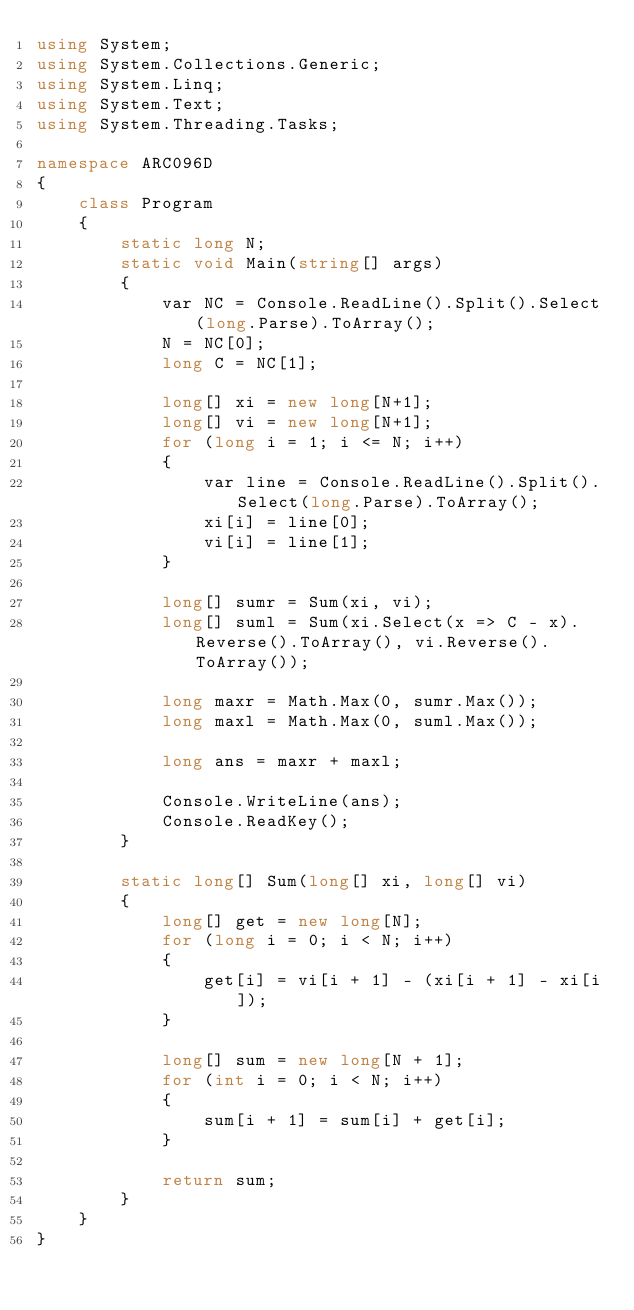Convert code to text. <code><loc_0><loc_0><loc_500><loc_500><_C#_>using System;
using System.Collections.Generic;
using System.Linq;
using System.Text;
using System.Threading.Tasks;

namespace ARC096D
{
    class Program
    {
        static long N;
        static void Main(string[] args)
        {
            var NC = Console.ReadLine().Split().Select(long.Parse).ToArray();
            N = NC[0];
            long C = NC[1];

            long[] xi = new long[N+1];
            long[] vi = new long[N+1];
            for (long i = 1; i <= N; i++)
            {
                var line = Console.ReadLine().Split().Select(long.Parse).ToArray();
                xi[i] = line[0];
                vi[i] = line[1];
            }

            long[] sumr = Sum(xi, vi);
            long[] suml = Sum(xi.Select(x => C - x).Reverse().ToArray(), vi.Reverse().ToArray());

            long maxr = Math.Max(0, sumr.Max());
            long maxl = Math.Max(0, suml.Max());

            long ans = maxr + maxl;

            Console.WriteLine(ans);
            Console.ReadKey();
        }

        static long[] Sum(long[] xi, long[] vi)
        {
            long[] get = new long[N];
            for (long i = 0; i < N; i++)
            {
                get[i] = vi[i + 1] - (xi[i + 1] - xi[i]);
            }

            long[] sum = new long[N + 1];
            for (int i = 0; i < N; i++)
            {
                sum[i + 1] = sum[i] + get[i];
            }

            return sum;
        }
    }
}
</code> 